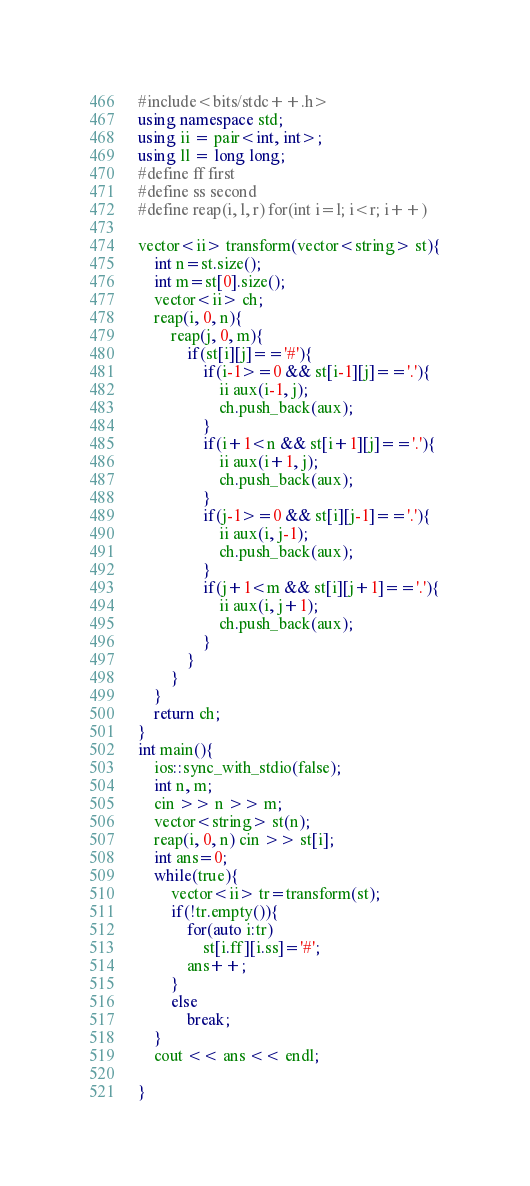Convert code to text. <code><loc_0><loc_0><loc_500><loc_500><_C++_>#include<bits/stdc++.h>
using namespace std;
using ii = pair<int, int>;
using ll = long long;
#define ff first
#define ss second
#define reap(i, l, r) for(int i=l; i<r; i++)

vector<ii> transform(vector<string> st){
	int n=st.size();
	int m=st[0].size();
	vector<ii> ch;
	reap(i, 0, n){
		reap(j, 0, m){
			if(st[i][j]=='#'){
				if(i-1>=0 && st[i-1][j]=='.'){
					ii aux(i-1, j);
					ch.push_back(aux);
				}
				if(i+1<n && st[i+1][j]=='.'){
					ii aux(i+1, j);
					ch.push_back(aux);
				}
				if(j-1>=0 && st[i][j-1]=='.'){
					ii aux(i, j-1);
					ch.push_back(aux);
				}
				if(j+1<m && st[i][j+1]=='.'){
					ii aux(i, j+1);
					ch.push_back(aux);
				}
			}
		}
	}
	return ch;
}
int main(){
	ios::sync_with_stdio(false);
	int n, m;
	cin >> n >> m;
	vector<string> st(n);
	reap(i, 0, n) cin >> st[i];
	int ans=0;
	while(true){
		vector<ii> tr=transform(st);
		if(!tr.empty()){
			for(auto i:tr)
				st[i.ff][i.ss]='#';
			ans++;
		}
		else
			break;
	}
	cout << ans << endl;

}
</code> 